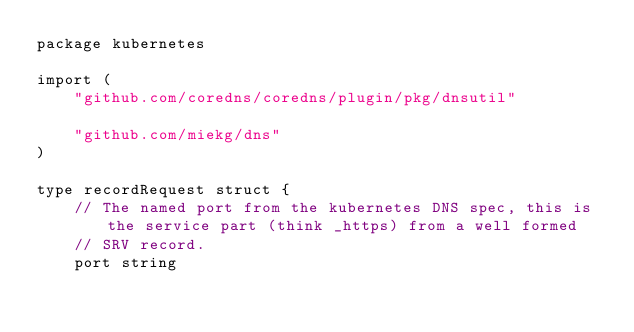<code> <loc_0><loc_0><loc_500><loc_500><_Go_>package kubernetes

import (
	"github.com/coredns/coredns/plugin/pkg/dnsutil"

	"github.com/miekg/dns"
)

type recordRequest struct {
	// The named port from the kubernetes DNS spec, this is the service part (think _https) from a well formed
	// SRV record.
	port string</code> 